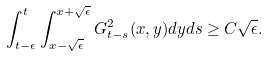<formula> <loc_0><loc_0><loc_500><loc_500>\int _ { t - \epsilon } ^ { t } \int _ { x - \sqrt { \epsilon } } ^ { x + \sqrt { \epsilon } } G ^ { 2 } _ { t - s } ( x , y ) d y d s \geq C \sqrt { \epsilon } .</formula> 